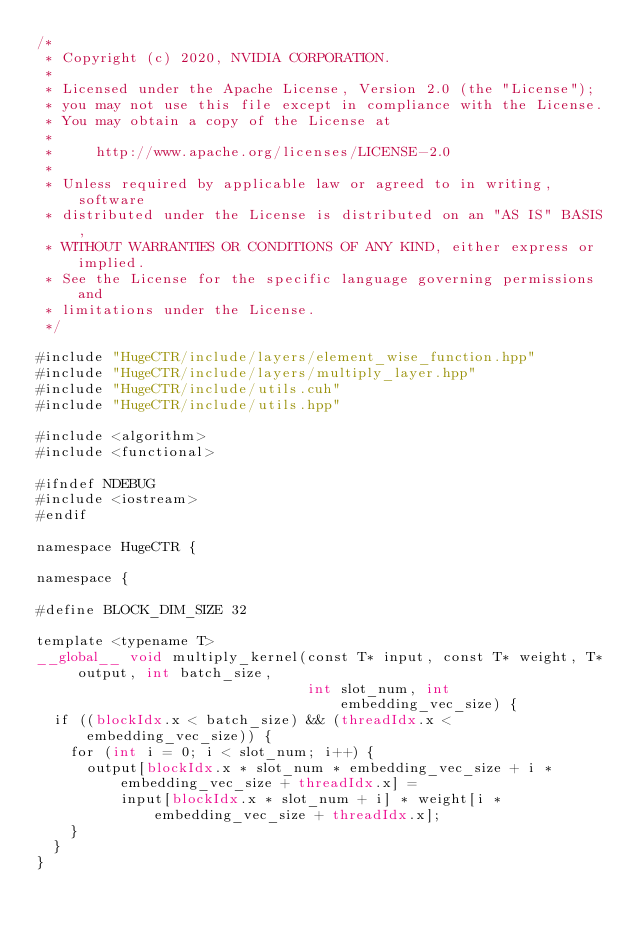<code> <loc_0><loc_0><loc_500><loc_500><_Cuda_>/*
 * Copyright (c) 2020, NVIDIA CORPORATION.
 *
 * Licensed under the Apache License, Version 2.0 (the "License");
 * you may not use this file except in compliance with the License.
 * You may obtain a copy of the License at
 *
 *     http://www.apache.org/licenses/LICENSE-2.0
 *
 * Unless required by applicable law or agreed to in writing, software
 * distributed under the License is distributed on an "AS IS" BASIS,
 * WITHOUT WARRANTIES OR CONDITIONS OF ANY KIND, either express or implied.
 * See the License for the specific language governing permissions and
 * limitations under the License.
 */

#include "HugeCTR/include/layers/element_wise_function.hpp"
#include "HugeCTR/include/layers/multiply_layer.hpp"
#include "HugeCTR/include/utils.cuh"
#include "HugeCTR/include/utils.hpp"

#include <algorithm>
#include <functional>

#ifndef NDEBUG
#include <iostream>
#endif

namespace HugeCTR {

namespace {

#define BLOCK_DIM_SIZE 32

template <typename T>
__global__ void multiply_kernel(const T* input, const T* weight, T* output, int batch_size,
                                int slot_num, int embedding_vec_size) {
  if ((blockIdx.x < batch_size) && (threadIdx.x < embedding_vec_size)) {
    for (int i = 0; i < slot_num; i++) {
      output[blockIdx.x * slot_num * embedding_vec_size + i * embedding_vec_size + threadIdx.x] =
          input[blockIdx.x * slot_num + i] * weight[i * embedding_vec_size + threadIdx.x];
    }
  }
}
</code> 